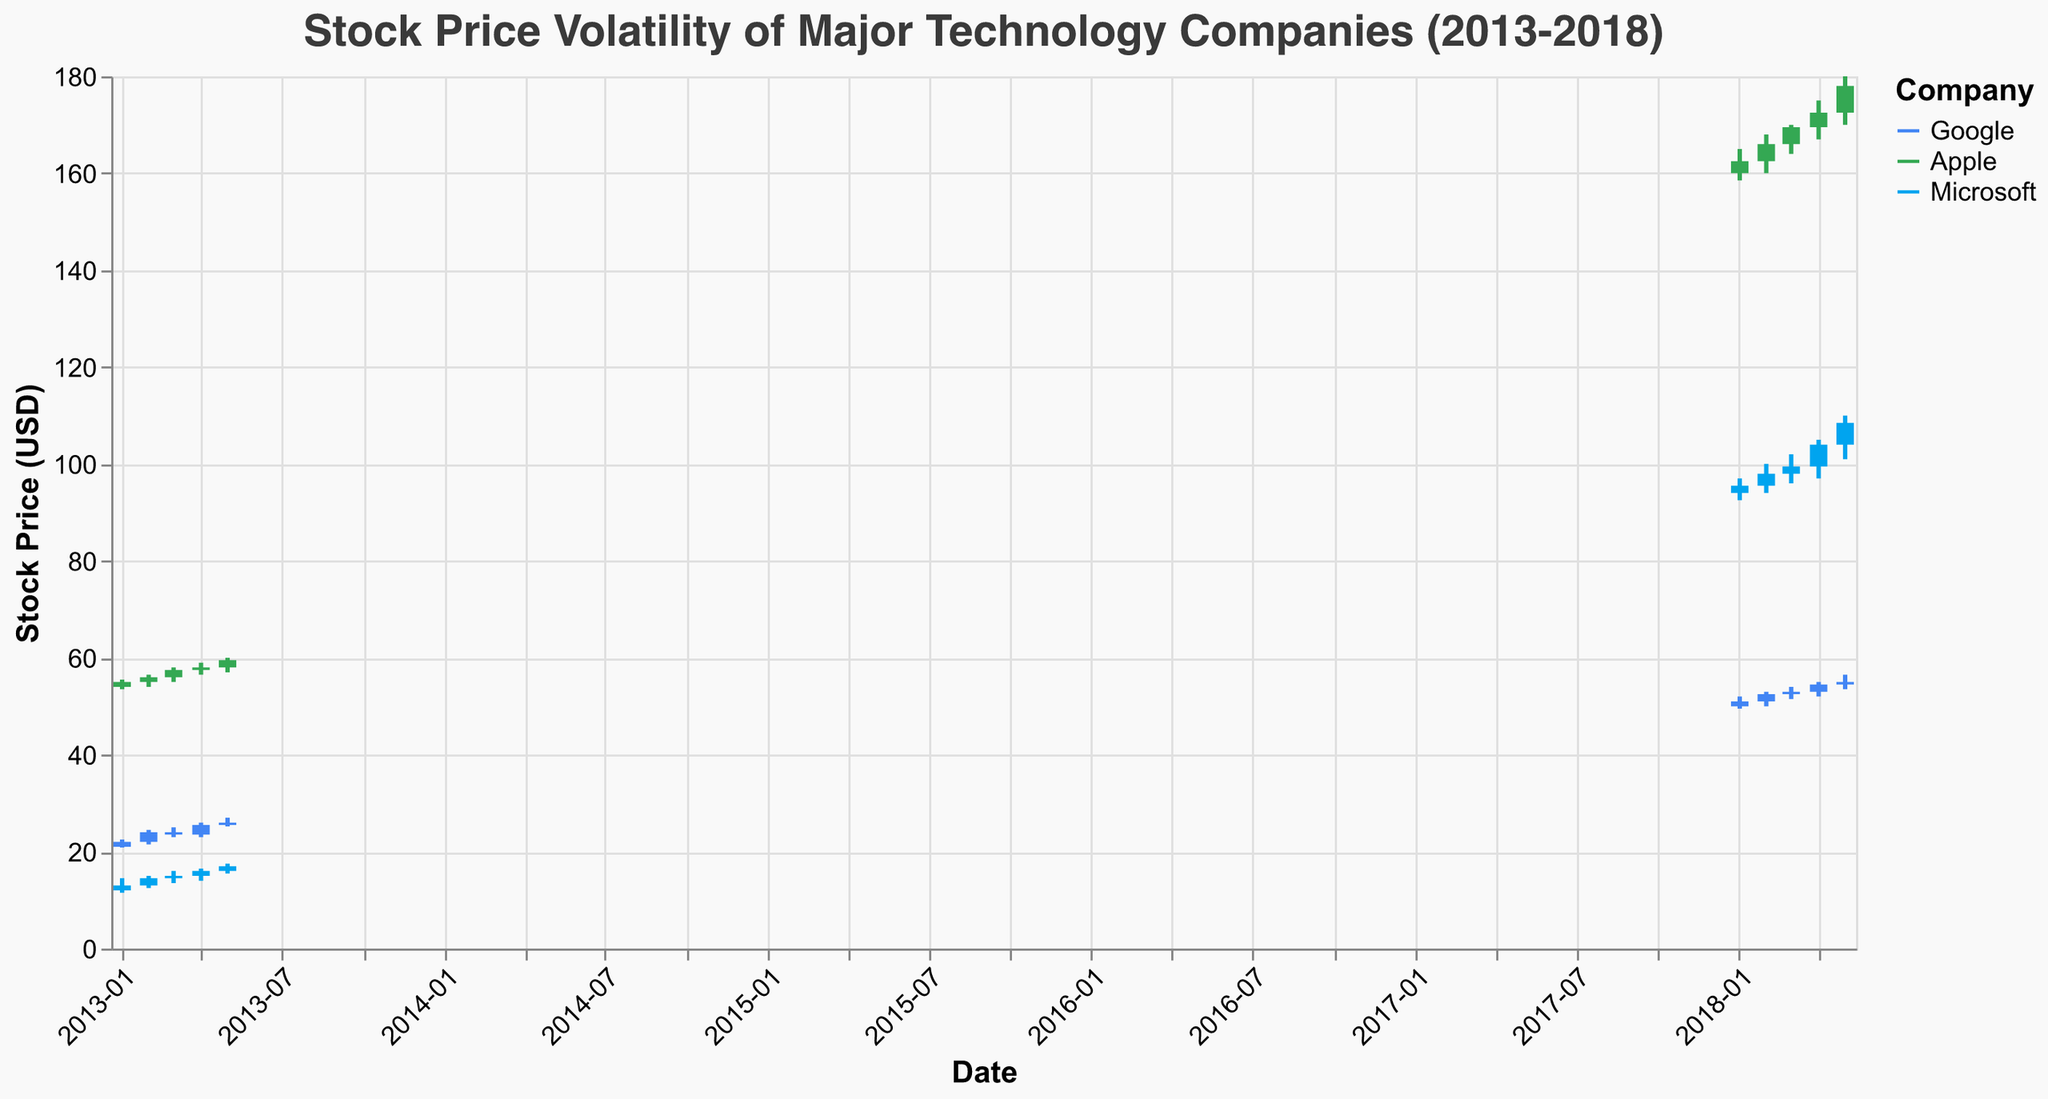What is the title of the plot? The title is positioned at the top of the plot, describing its content.
Answer: Stock Price Volatility of Major Technology Companies (2013-2018) How many companies are represented in the plot? There are three colors in the plot legend, each representing a different company.
Answer: 3 Which company had the highest stock price in May 2018? To find this, look at the highest candlestick for May 2018 across all companies. Apple's candlestick reaches the highest point.
Answer: Apple What is the color used for Google's candlestick lines? The color for Google's candlesticks is described in the legend and used consistently across the plot. Google's color is blue.
Answer: Blue In which month of 2013 did Microsoft have the largest closing price? To determine this, trace Microsoft's closing prices for the months in 2013. The highest closing price for Microsoft in 2013 is 17.00 in May.
Answer: May What is the percentage increase in Apple's opening prices from January 2013 to January 2018? First, find the opening prices for Apple in January 2013 (54.00) and January 2018 (160.00). Then compute the percentage increase: ((160.00 - 54.00) / 54.00) * 100 = 196.3%
Answer: 196.3% How does Google's stock price change between February and March 2013? The change is found by comparing the closing and opening prices for February (24.00) and March (24.00 opening, 23.50 closing). Hence, there's a slight decrease.
Answer: It decreases Which company had the highest volatility in May 2013? Volatility can be approximated by the difference between the high and low prices in a month. Calculate this for each company in May 2013: Google (27.00 - 25.20 = 1.80), Apple (60.00 - 57.00 = 3.00), Microsoft (17.50 - 15.50 = 2.00). Apple's volatility is highest.
Answer: Apple What is the average closing price of Microsoft across all months in 2018? Collect Microsoft's closing prices from each month in 2018 (95.50, 98.00, 99.50, 104.00, 108.50), sum them up (105.50 + 98.00 + 99.50 + 104.00 + 108.50 = 505.50), and divide by the number of months (505.50 / 5).
Answer: 101.10 How does the volume of stock traded for each company compare in January 2018? Check the volume of Google (11000000), Apple (12000000), and Microsoft (11000000) in January 2018. Apple has the highest volume, and both Google and Microsoft are equal and next highest.
Answer: Apple > Google = Microsoft 